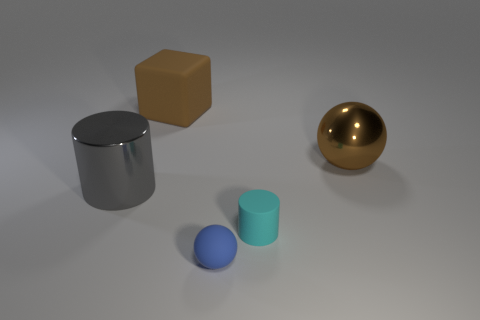Add 5 brown metal things. How many objects exist? 10 Subtract all cubes. How many objects are left? 4 Add 2 small matte things. How many small matte things exist? 4 Subtract 1 brown balls. How many objects are left? 4 Subtract all brown matte blocks. Subtract all brown balls. How many objects are left? 3 Add 2 large gray metal cylinders. How many large gray metal cylinders are left? 3 